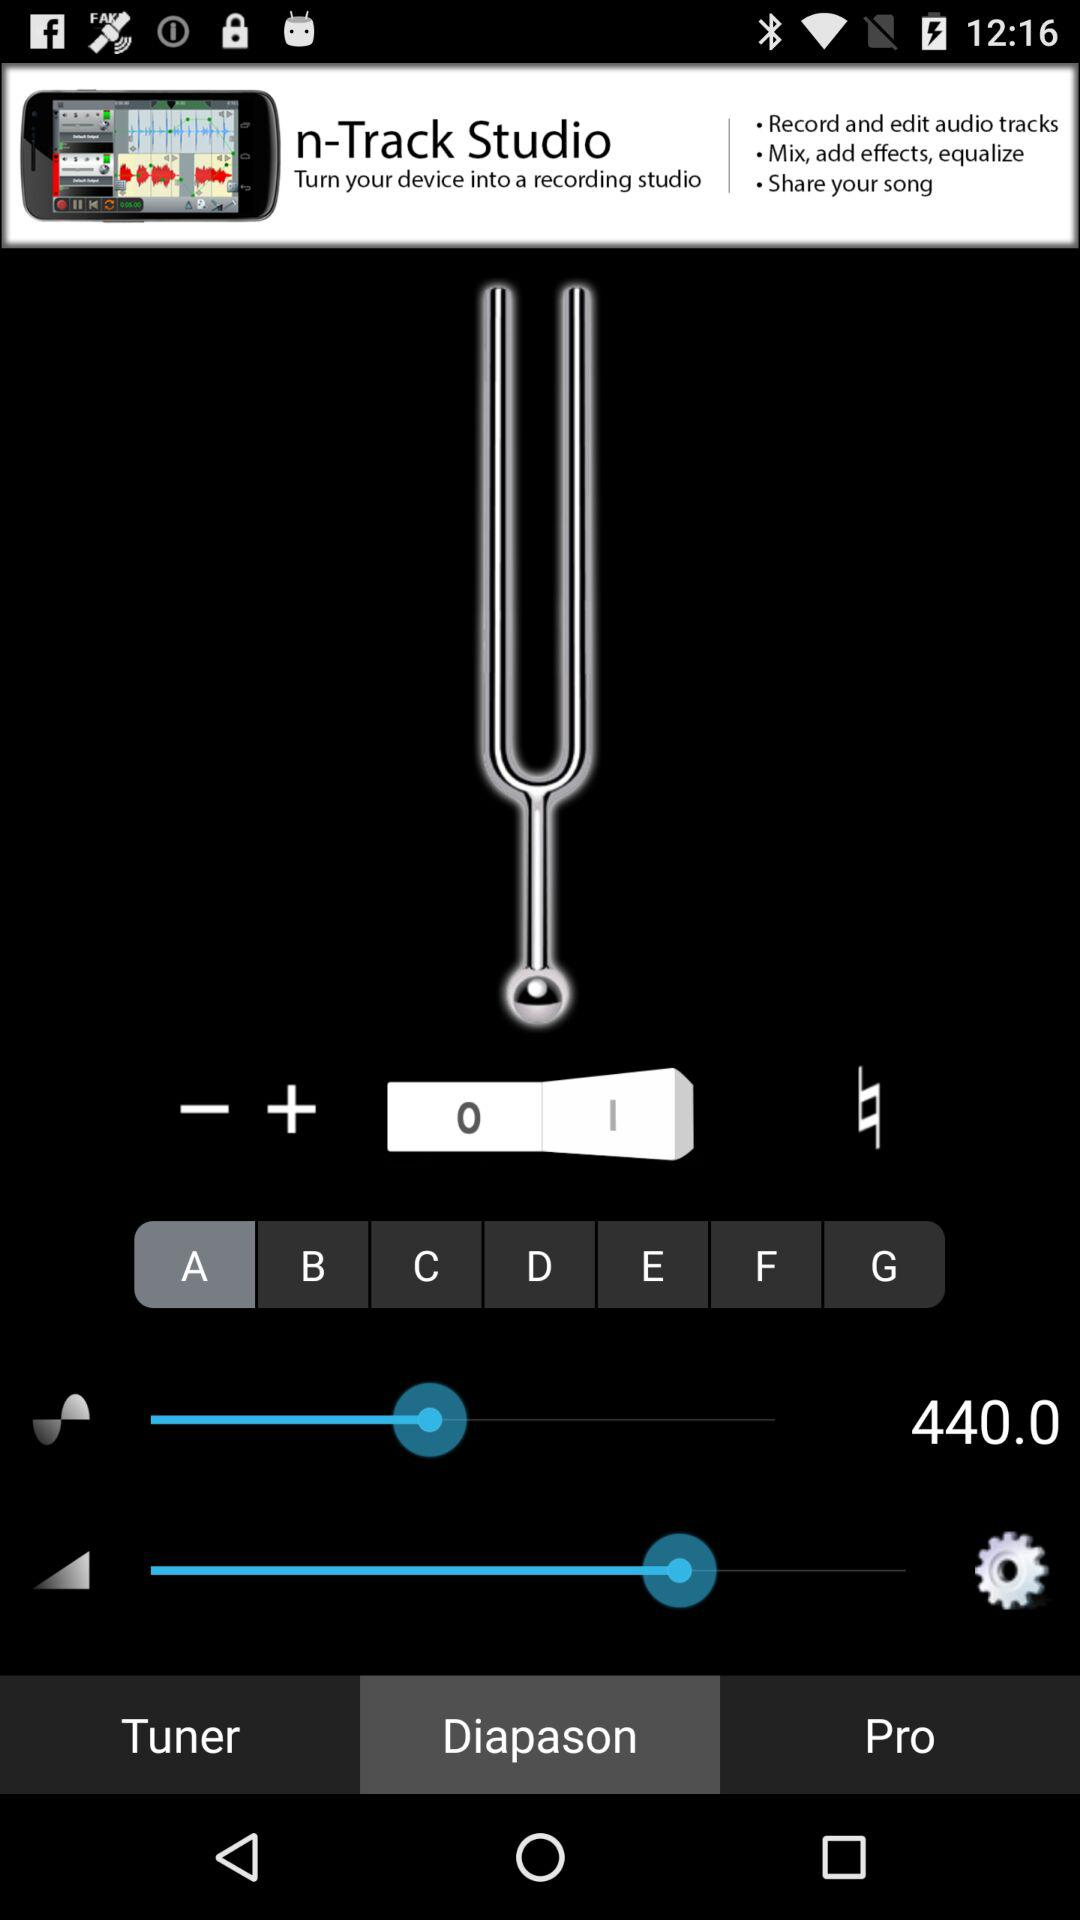Which tab is currently selected? The currently selected tabs are "A" and "Diapason". 